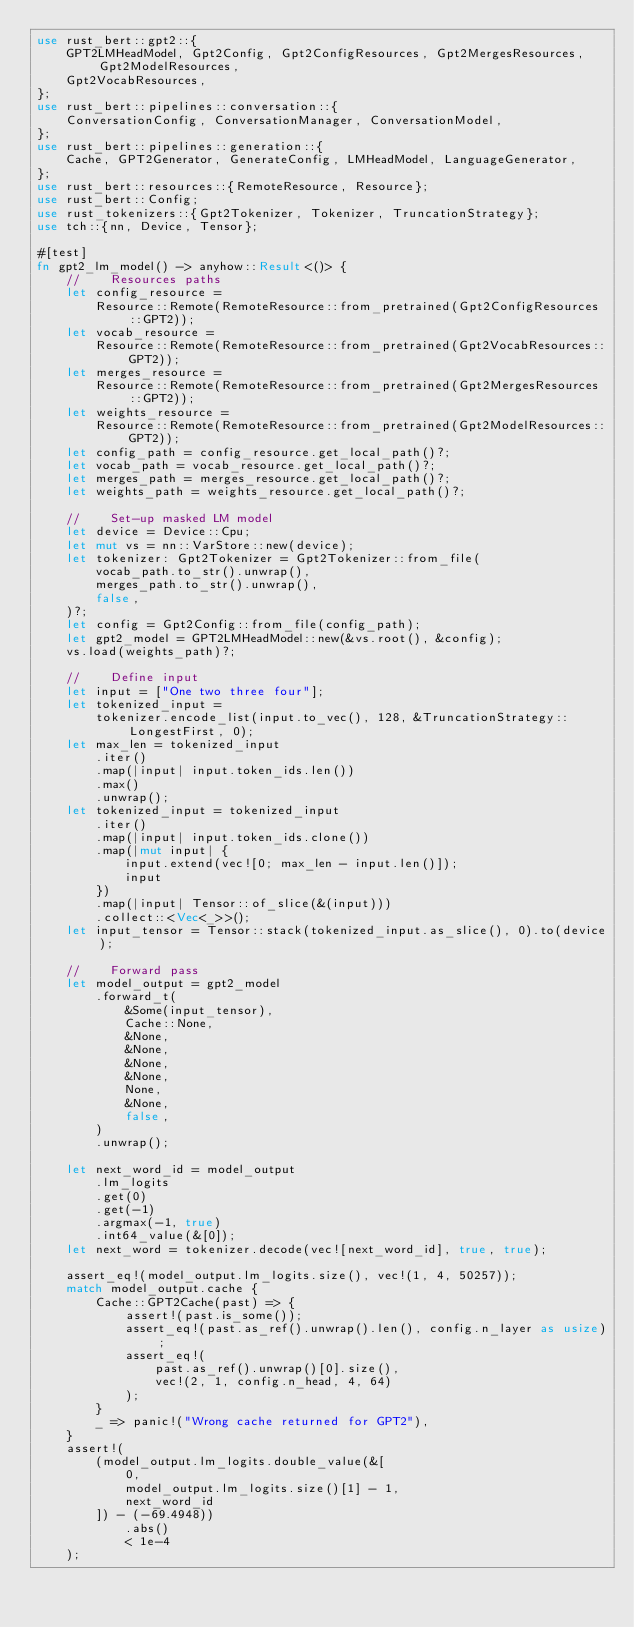<code> <loc_0><loc_0><loc_500><loc_500><_Rust_>use rust_bert::gpt2::{
    GPT2LMHeadModel, Gpt2Config, Gpt2ConfigResources, Gpt2MergesResources, Gpt2ModelResources,
    Gpt2VocabResources,
};
use rust_bert::pipelines::conversation::{
    ConversationConfig, ConversationManager, ConversationModel,
};
use rust_bert::pipelines::generation::{
    Cache, GPT2Generator, GenerateConfig, LMHeadModel, LanguageGenerator,
};
use rust_bert::resources::{RemoteResource, Resource};
use rust_bert::Config;
use rust_tokenizers::{Gpt2Tokenizer, Tokenizer, TruncationStrategy};
use tch::{nn, Device, Tensor};

#[test]
fn gpt2_lm_model() -> anyhow::Result<()> {
    //    Resources paths
    let config_resource =
        Resource::Remote(RemoteResource::from_pretrained(Gpt2ConfigResources::GPT2));
    let vocab_resource =
        Resource::Remote(RemoteResource::from_pretrained(Gpt2VocabResources::GPT2));
    let merges_resource =
        Resource::Remote(RemoteResource::from_pretrained(Gpt2MergesResources::GPT2));
    let weights_resource =
        Resource::Remote(RemoteResource::from_pretrained(Gpt2ModelResources::GPT2));
    let config_path = config_resource.get_local_path()?;
    let vocab_path = vocab_resource.get_local_path()?;
    let merges_path = merges_resource.get_local_path()?;
    let weights_path = weights_resource.get_local_path()?;

    //    Set-up masked LM model
    let device = Device::Cpu;
    let mut vs = nn::VarStore::new(device);
    let tokenizer: Gpt2Tokenizer = Gpt2Tokenizer::from_file(
        vocab_path.to_str().unwrap(),
        merges_path.to_str().unwrap(),
        false,
    )?;
    let config = Gpt2Config::from_file(config_path);
    let gpt2_model = GPT2LMHeadModel::new(&vs.root(), &config);
    vs.load(weights_path)?;

    //    Define input
    let input = ["One two three four"];
    let tokenized_input =
        tokenizer.encode_list(input.to_vec(), 128, &TruncationStrategy::LongestFirst, 0);
    let max_len = tokenized_input
        .iter()
        .map(|input| input.token_ids.len())
        .max()
        .unwrap();
    let tokenized_input = tokenized_input
        .iter()
        .map(|input| input.token_ids.clone())
        .map(|mut input| {
            input.extend(vec![0; max_len - input.len()]);
            input
        })
        .map(|input| Tensor::of_slice(&(input)))
        .collect::<Vec<_>>();
    let input_tensor = Tensor::stack(tokenized_input.as_slice(), 0).to(device);

    //    Forward pass
    let model_output = gpt2_model
        .forward_t(
            &Some(input_tensor),
            Cache::None,
            &None,
            &None,
            &None,
            &None,
            None,
            &None,
            false,
        )
        .unwrap();

    let next_word_id = model_output
        .lm_logits
        .get(0)
        .get(-1)
        .argmax(-1, true)
        .int64_value(&[0]);
    let next_word = tokenizer.decode(vec![next_word_id], true, true);

    assert_eq!(model_output.lm_logits.size(), vec!(1, 4, 50257));
    match model_output.cache {
        Cache::GPT2Cache(past) => {
            assert!(past.is_some());
            assert_eq!(past.as_ref().unwrap().len(), config.n_layer as usize);
            assert_eq!(
                past.as_ref().unwrap()[0].size(),
                vec!(2, 1, config.n_head, 4, 64)
            );
        }
        _ => panic!("Wrong cache returned for GPT2"),
    }
    assert!(
        (model_output.lm_logits.double_value(&[
            0,
            model_output.lm_logits.size()[1] - 1,
            next_word_id
        ]) - (-69.4948))
            .abs()
            < 1e-4
    );</code> 